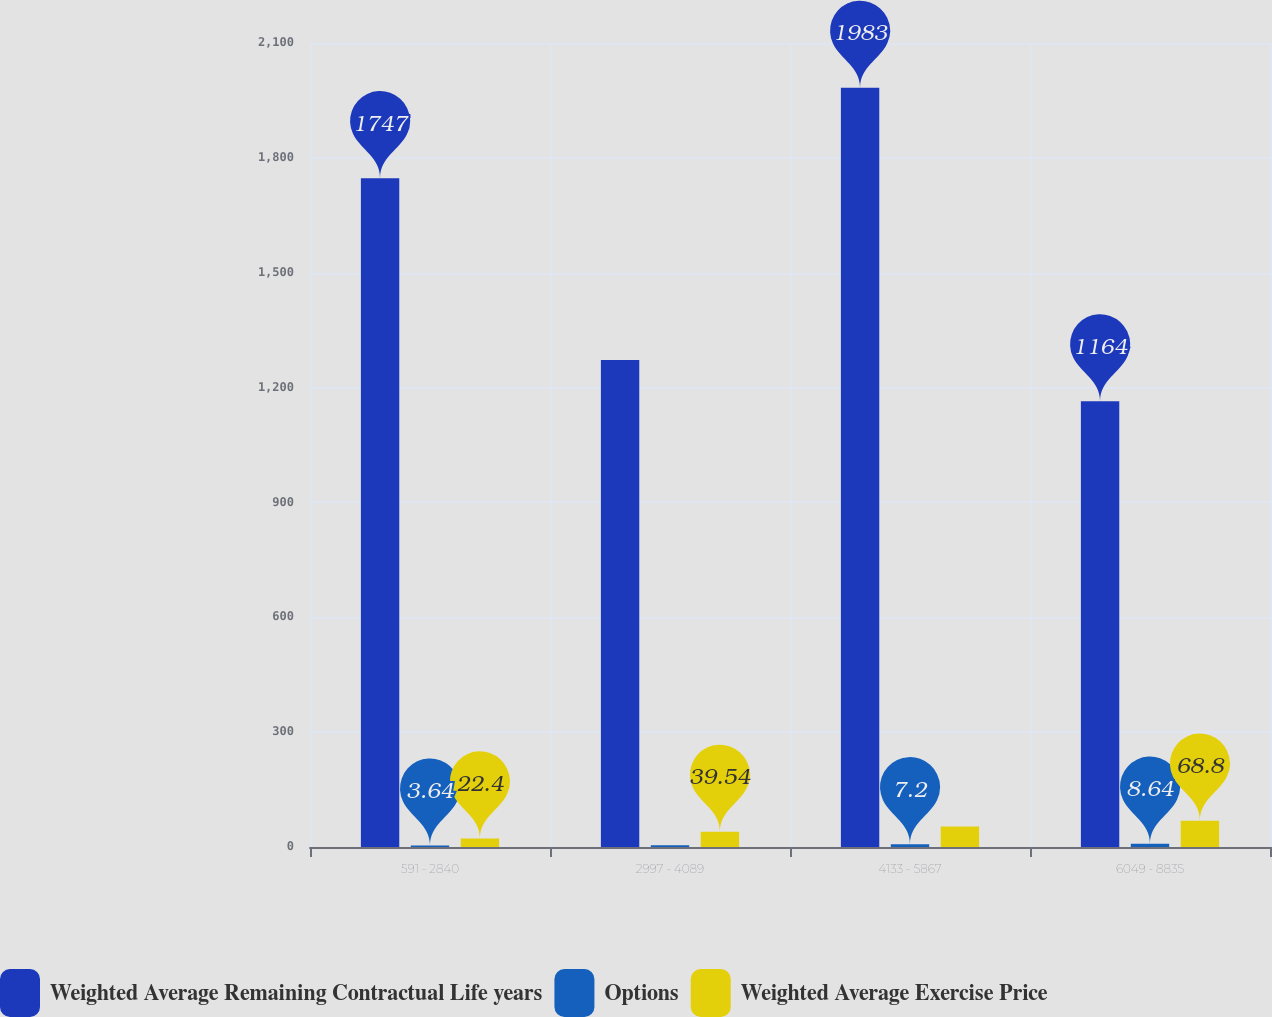Convert chart to OTSL. <chart><loc_0><loc_0><loc_500><loc_500><stacked_bar_chart><ecel><fcel>591 - 2840<fcel>2997 - 4089<fcel>4133 - 5867<fcel>6049 - 8835<nl><fcel>Weighted Average Remaining Contractual Life years<fcel>1747<fcel>1272<fcel>1983<fcel>1164<nl><fcel>Options<fcel>3.64<fcel>4.79<fcel>7.2<fcel>8.64<nl><fcel>Weighted Average Exercise Price<fcel>22.4<fcel>39.54<fcel>53.73<fcel>68.8<nl></chart> 